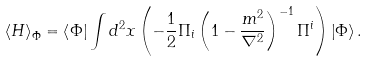Convert formula to latex. <formula><loc_0><loc_0><loc_500><loc_500>\left \langle H \right \rangle _ { \Phi } = \left \langle \Phi \right | \int { d ^ { 2 } x } \left ( { - \frac { 1 } { 2 } \Pi _ { i } \left ( { 1 - \frac { m ^ { 2 } } { \nabla ^ { 2 } } } \right ) ^ { - 1 } \Pi ^ { i } } \right ) \left | \Phi \right \rangle .</formula> 